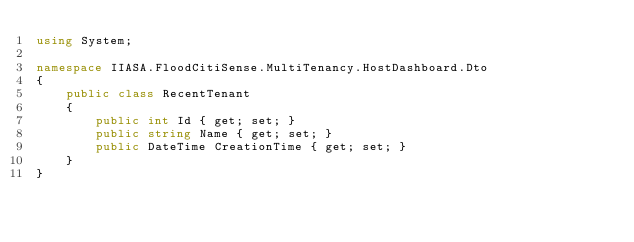<code> <loc_0><loc_0><loc_500><loc_500><_C#_>using System;

namespace IIASA.FloodCitiSense.MultiTenancy.HostDashboard.Dto
{
    public class RecentTenant
    {
        public int Id { get; set; }
        public string Name { get; set; }
        public DateTime CreationTime { get; set; }
    }
}</code> 